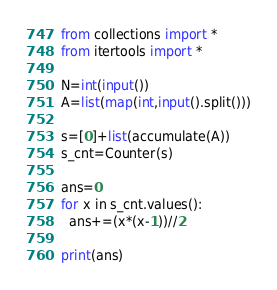<code> <loc_0><loc_0><loc_500><loc_500><_Python_>from collections import *
from itertools import *

N=int(input())
A=list(map(int,input().split()))

s=[0]+list(accumulate(A))
s_cnt=Counter(s)

ans=0
for x in s_cnt.values():
  ans+=(x*(x-1))//2

print(ans)
</code> 